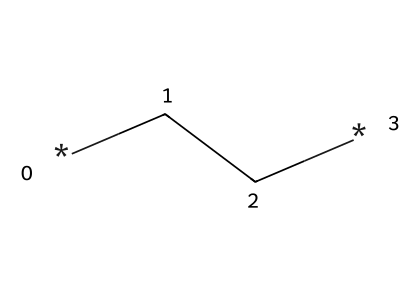What is the molecular formula of this compound? The compound represented by the SMILES CC consists of two carbon atoms (C) and six hydrogen atoms (H), leading to the molecular formula C2H6.
Answer: C2H6 How many carbon-carbon bonds are present in this molecule? The SMILES representation CC indicates a single bond between the two carbon atoms, leading to one carbon-carbon bond.
Answer: 1 What type of bonds are present in this compound? The SMILES CC denotes that the connections between the carbon atoms are single bonds, which are characteristic of saturated hydrocarbons.
Answer: single bonds Is this compound saturated or unsaturated? Since it contains only single bonds between carbon atoms and has the maximum number of hydrogen atoms, it is classified as a saturated hydrocarbon.
Answer: saturated What category of chemical compound does this belong to? The SMILES representation CC indicates that this molecule is an aliphatic compound because it consists of carbon and hydrogen in a straight or branched chain without aromatic rings.
Answer: aliphatic How many hydrogen atoms are bonded to each carbon in this molecule? Each carbon in the molecule (C2H6) is bonded to three hydrogen atoms, making it a fully saturated structure.
Answer: 3 